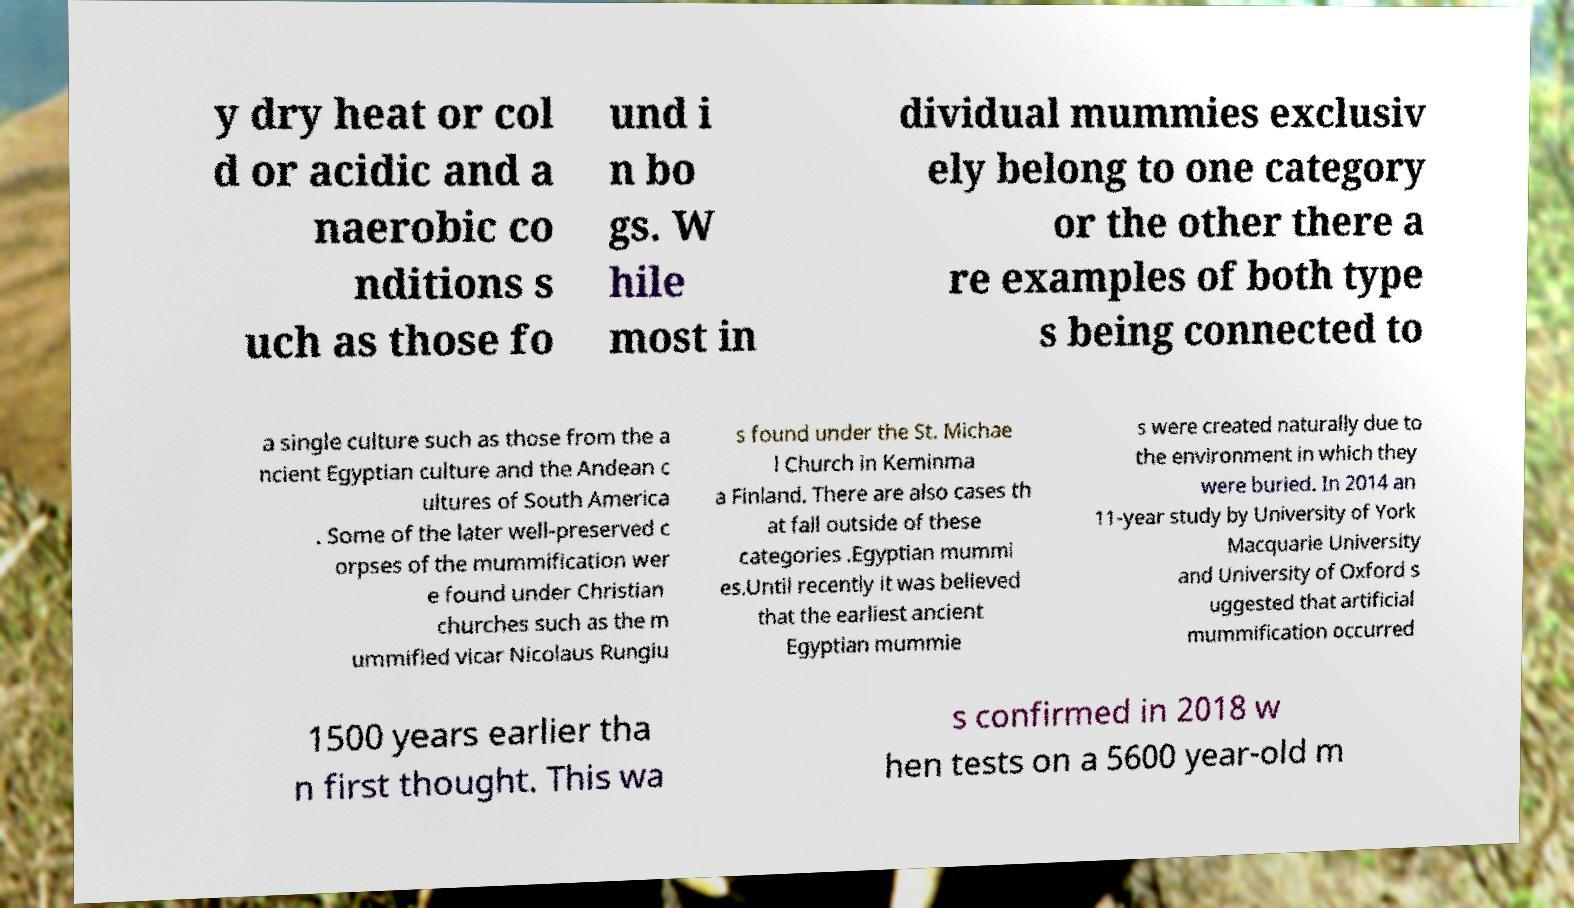What messages or text are displayed in this image? I need them in a readable, typed format. y dry heat or col d or acidic and a naerobic co nditions s uch as those fo und i n bo gs. W hile most in dividual mummies exclusiv ely belong to one category or the other there a re examples of both type s being connected to a single culture such as those from the a ncient Egyptian culture and the Andean c ultures of South America . Some of the later well-preserved c orpses of the mummification wer e found under Christian churches such as the m ummified vicar Nicolaus Rungiu s found under the St. Michae l Church in Keminma a Finland. There are also cases th at fall outside of these categories .Egyptian mummi es.Until recently it was believed that the earliest ancient Egyptian mummie s were created naturally due to the environment in which they were buried. In 2014 an 11-year study by University of York Macquarie University and University of Oxford s uggested that artificial mummification occurred 1500 years earlier tha n first thought. This wa s confirmed in 2018 w hen tests on a 5600 year-old m 